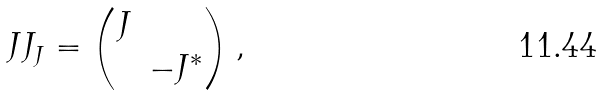Convert formula to latex. <formula><loc_0><loc_0><loc_500><loc_500>\ J J _ { J } = \left ( \begin{matrix} J & \\ & - J ^ { * } \end{matrix} \right ) ,</formula> 